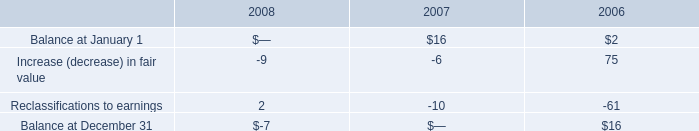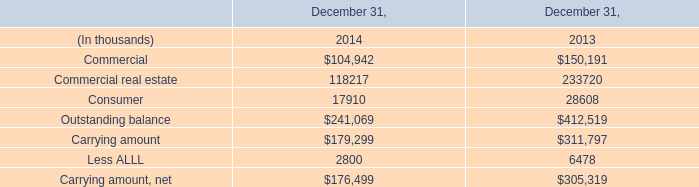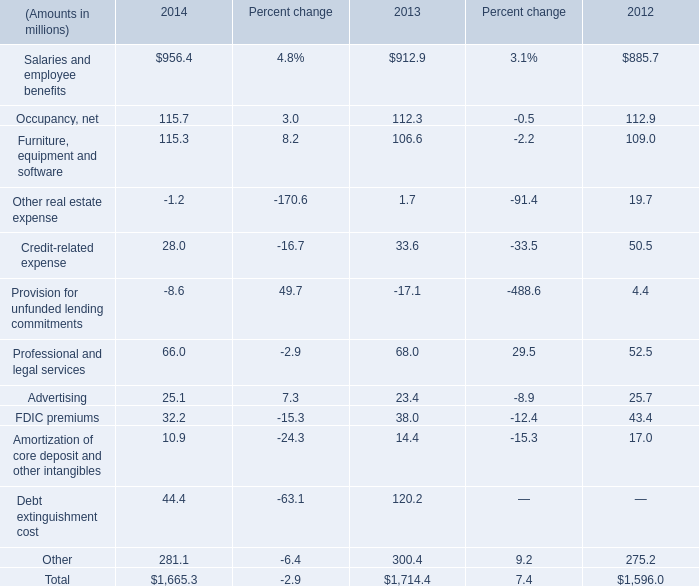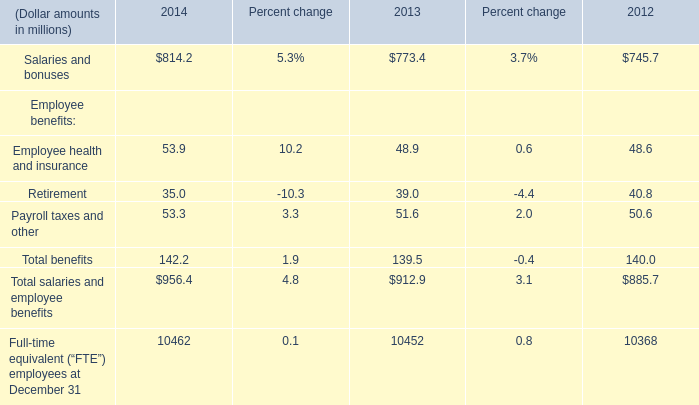As As the chart 3 shows,which year is the value of the Total salaries and employee benefits the highest? 
Answer: 2014. 